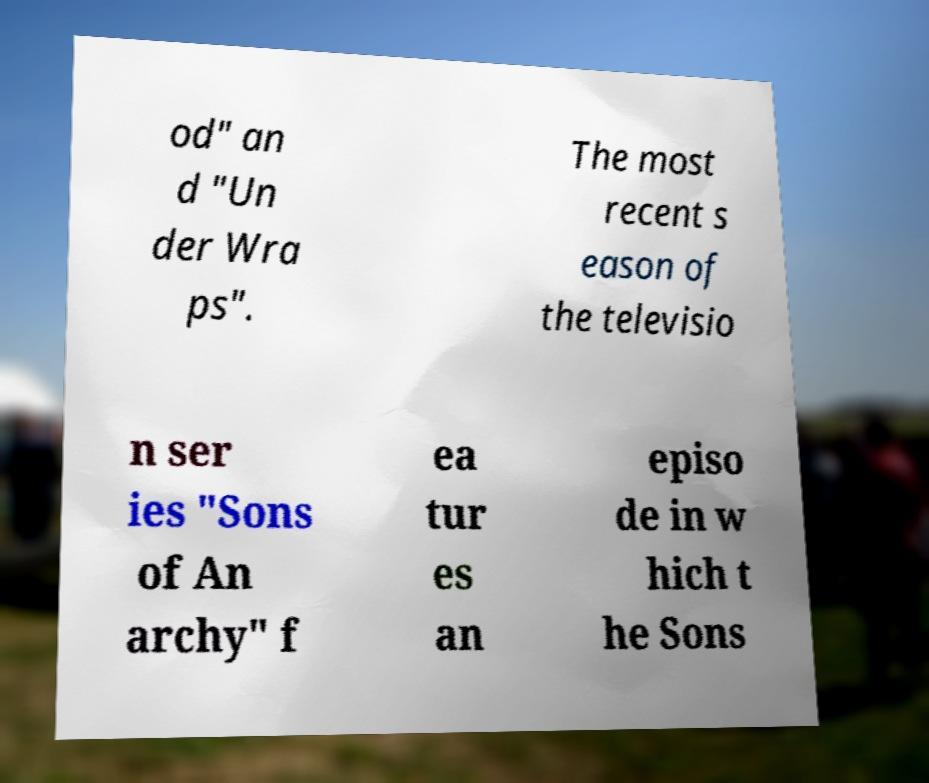For documentation purposes, I need the text within this image transcribed. Could you provide that? od" an d "Un der Wra ps". The most recent s eason of the televisio n ser ies "Sons of An archy" f ea tur es an episo de in w hich t he Sons 